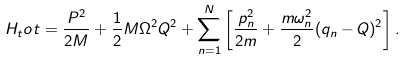<formula> <loc_0><loc_0><loc_500><loc_500>H _ { t } o t = \frac { P ^ { 2 } } { 2 M } + \frac { 1 } { 2 } M \Omega ^ { 2 } Q ^ { 2 } + \sum _ { n = 1 } ^ { N } \left [ \frac { p _ { n } ^ { 2 } } { 2 m } + \frac { m \omega _ { n } ^ { 2 } } { 2 } ( q _ { n } - Q ) ^ { 2 } \right ] .</formula> 